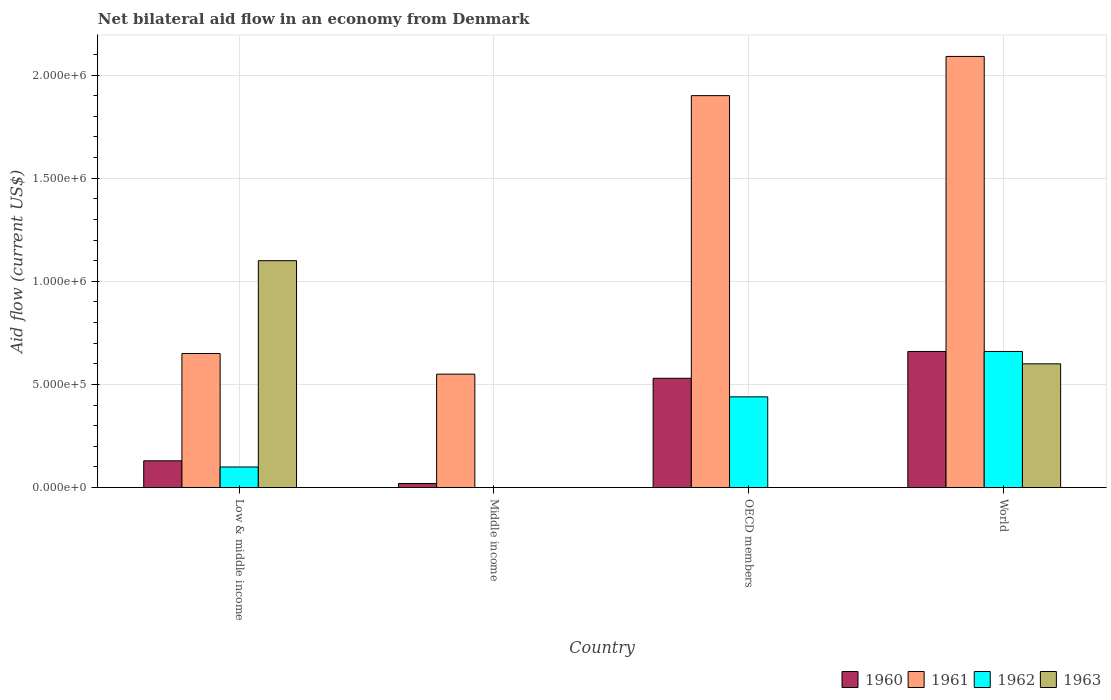How many groups of bars are there?
Keep it short and to the point. 4. How many bars are there on the 2nd tick from the right?
Offer a very short reply. 3. In which country was the net bilateral aid flow in 1963 maximum?
Offer a very short reply. Low & middle income. What is the total net bilateral aid flow in 1961 in the graph?
Provide a short and direct response. 5.19e+06. What is the difference between the net bilateral aid flow in 1960 in Middle income and that in World?
Ensure brevity in your answer.  -6.40e+05. What is the difference between the net bilateral aid flow in 1961 in Middle income and the net bilateral aid flow in 1960 in World?
Make the answer very short. -1.10e+05. What is the average net bilateral aid flow in 1961 per country?
Your response must be concise. 1.30e+06. What is the difference between the net bilateral aid flow of/in 1963 and net bilateral aid flow of/in 1960 in Low & middle income?
Offer a very short reply. 9.70e+05. In how many countries, is the net bilateral aid flow in 1961 greater than 600000 US$?
Keep it short and to the point. 3. What is the ratio of the net bilateral aid flow in 1961 in OECD members to that in World?
Give a very brief answer. 0.91. Is the net bilateral aid flow in 1961 in Middle income less than that in OECD members?
Keep it short and to the point. Yes. What is the difference between the highest and the lowest net bilateral aid flow in 1963?
Your response must be concise. 1.10e+06. Is the sum of the net bilateral aid flow in 1961 in OECD members and World greater than the maximum net bilateral aid flow in 1963 across all countries?
Your answer should be very brief. Yes. Is it the case that in every country, the sum of the net bilateral aid flow in 1963 and net bilateral aid flow in 1961 is greater than the net bilateral aid flow in 1962?
Provide a succinct answer. Yes. Are all the bars in the graph horizontal?
Provide a succinct answer. No. Does the graph contain any zero values?
Give a very brief answer. Yes. Does the graph contain grids?
Keep it short and to the point. Yes. Where does the legend appear in the graph?
Your response must be concise. Bottom right. How many legend labels are there?
Ensure brevity in your answer.  4. What is the title of the graph?
Give a very brief answer. Net bilateral aid flow in an economy from Denmark. What is the Aid flow (current US$) of 1961 in Low & middle income?
Make the answer very short. 6.50e+05. What is the Aid flow (current US$) in 1963 in Low & middle income?
Offer a very short reply. 1.10e+06. What is the Aid flow (current US$) of 1960 in Middle income?
Offer a terse response. 2.00e+04. What is the Aid flow (current US$) of 1962 in Middle income?
Your answer should be very brief. 0. What is the Aid flow (current US$) in 1960 in OECD members?
Offer a very short reply. 5.30e+05. What is the Aid flow (current US$) of 1961 in OECD members?
Make the answer very short. 1.90e+06. What is the Aid flow (current US$) in 1963 in OECD members?
Offer a terse response. 0. What is the Aid flow (current US$) in 1961 in World?
Keep it short and to the point. 2.09e+06. Across all countries, what is the maximum Aid flow (current US$) of 1961?
Offer a very short reply. 2.09e+06. Across all countries, what is the maximum Aid flow (current US$) in 1962?
Your answer should be very brief. 6.60e+05. Across all countries, what is the maximum Aid flow (current US$) of 1963?
Your answer should be compact. 1.10e+06. Across all countries, what is the minimum Aid flow (current US$) in 1960?
Your answer should be compact. 2.00e+04. Across all countries, what is the minimum Aid flow (current US$) of 1963?
Provide a succinct answer. 0. What is the total Aid flow (current US$) in 1960 in the graph?
Keep it short and to the point. 1.34e+06. What is the total Aid flow (current US$) in 1961 in the graph?
Ensure brevity in your answer.  5.19e+06. What is the total Aid flow (current US$) in 1962 in the graph?
Give a very brief answer. 1.20e+06. What is the total Aid flow (current US$) of 1963 in the graph?
Your answer should be very brief. 1.70e+06. What is the difference between the Aid flow (current US$) of 1961 in Low & middle income and that in Middle income?
Offer a terse response. 1.00e+05. What is the difference between the Aid flow (current US$) in 1960 in Low & middle income and that in OECD members?
Provide a succinct answer. -4.00e+05. What is the difference between the Aid flow (current US$) of 1961 in Low & middle income and that in OECD members?
Offer a very short reply. -1.25e+06. What is the difference between the Aid flow (current US$) of 1960 in Low & middle income and that in World?
Offer a very short reply. -5.30e+05. What is the difference between the Aid flow (current US$) of 1961 in Low & middle income and that in World?
Provide a short and direct response. -1.44e+06. What is the difference between the Aid flow (current US$) in 1962 in Low & middle income and that in World?
Your answer should be compact. -5.60e+05. What is the difference between the Aid flow (current US$) in 1960 in Middle income and that in OECD members?
Ensure brevity in your answer.  -5.10e+05. What is the difference between the Aid flow (current US$) of 1961 in Middle income and that in OECD members?
Your response must be concise. -1.35e+06. What is the difference between the Aid flow (current US$) in 1960 in Middle income and that in World?
Keep it short and to the point. -6.40e+05. What is the difference between the Aid flow (current US$) in 1961 in Middle income and that in World?
Your answer should be very brief. -1.54e+06. What is the difference between the Aid flow (current US$) in 1962 in OECD members and that in World?
Offer a terse response. -2.20e+05. What is the difference between the Aid flow (current US$) of 1960 in Low & middle income and the Aid flow (current US$) of 1961 in Middle income?
Give a very brief answer. -4.20e+05. What is the difference between the Aid flow (current US$) of 1960 in Low & middle income and the Aid flow (current US$) of 1961 in OECD members?
Keep it short and to the point. -1.77e+06. What is the difference between the Aid flow (current US$) of 1960 in Low & middle income and the Aid flow (current US$) of 1962 in OECD members?
Offer a terse response. -3.10e+05. What is the difference between the Aid flow (current US$) in 1961 in Low & middle income and the Aid flow (current US$) in 1962 in OECD members?
Your response must be concise. 2.10e+05. What is the difference between the Aid flow (current US$) of 1960 in Low & middle income and the Aid flow (current US$) of 1961 in World?
Your answer should be compact. -1.96e+06. What is the difference between the Aid flow (current US$) in 1960 in Low & middle income and the Aid flow (current US$) in 1962 in World?
Give a very brief answer. -5.30e+05. What is the difference between the Aid flow (current US$) of 1960 in Low & middle income and the Aid flow (current US$) of 1963 in World?
Offer a very short reply. -4.70e+05. What is the difference between the Aid flow (current US$) of 1961 in Low & middle income and the Aid flow (current US$) of 1962 in World?
Keep it short and to the point. -10000. What is the difference between the Aid flow (current US$) in 1962 in Low & middle income and the Aid flow (current US$) in 1963 in World?
Your answer should be compact. -5.00e+05. What is the difference between the Aid flow (current US$) of 1960 in Middle income and the Aid flow (current US$) of 1961 in OECD members?
Offer a very short reply. -1.88e+06. What is the difference between the Aid flow (current US$) of 1960 in Middle income and the Aid flow (current US$) of 1962 in OECD members?
Keep it short and to the point. -4.20e+05. What is the difference between the Aid flow (current US$) in 1960 in Middle income and the Aid flow (current US$) in 1961 in World?
Provide a succinct answer. -2.07e+06. What is the difference between the Aid flow (current US$) in 1960 in Middle income and the Aid flow (current US$) in 1962 in World?
Offer a terse response. -6.40e+05. What is the difference between the Aid flow (current US$) of 1960 in Middle income and the Aid flow (current US$) of 1963 in World?
Give a very brief answer. -5.80e+05. What is the difference between the Aid flow (current US$) in 1960 in OECD members and the Aid flow (current US$) in 1961 in World?
Provide a succinct answer. -1.56e+06. What is the difference between the Aid flow (current US$) of 1960 in OECD members and the Aid flow (current US$) of 1962 in World?
Make the answer very short. -1.30e+05. What is the difference between the Aid flow (current US$) of 1961 in OECD members and the Aid flow (current US$) of 1962 in World?
Your answer should be very brief. 1.24e+06. What is the difference between the Aid flow (current US$) in 1961 in OECD members and the Aid flow (current US$) in 1963 in World?
Ensure brevity in your answer.  1.30e+06. What is the difference between the Aid flow (current US$) of 1962 in OECD members and the Aid flow (current US$) of 1963 in World?
Ensure brevity in your answer.  -1.60e+05. What is the average Aid flow (current US$) of 1960 per country?
Keep it short and to the point. 3.35e+05. What is the average Aid flow (current US$) in 1961 per country?
Offer a terse response. 1.30e+06. What is the average Aid flow (current US$) of 1963 per country?
Offer a very short reply. 4.25e+05. What is the difference between the Aid flow (current US$) of 1960 and Aid flow (current US$) of 1961 in Low & middle income?
Your answer should be compact. -5.20e+05. What is the difference between the Aid flow (current US$) in 1960 and Aid flow (current US$) in 1963 in Low & middle income?
Make the answer very short. -9.70e+05. What is the difference between the Aid flow (current US$) in 1961 and Aid flow (current US$) in 1962 in Low & middle income?
Provide a short and direct response. 5.50e+05. What is the difference between the Aid flow (current US$) of 1961 and Aid flow (current US$) of 1963 in Low & middle income?
Your response must be concise. -4.50e+05. What is the difference between the Aid flow (current US$) in 1962 and Aid flow (current US$) in 1963 in Low & middle income?
Provide a short and direct response. -1.00e+06. What is the difference between the Aid flow (current US$) of 1960 and Aid flow (current US$) of 1961 in Middle income?
Your answer should be compact. -5.30e+05. What is the difference between the Aid flow (current US$) of 1960 and Aid flow (current US$) of 1961 in OECD members?
Your response must be concise. -1.37e+06. What is the difference between the Aid flow (current US$) of 1960 and Aid flow (current US$) of 1962 in OECD members?
Offer a terse response. 9.00e+04. What is the difference between the Aid flow (current US$) in 1961 and Aid flow (current US$) in 1962 in OECD members?
Ensure brevity in your answer.  1.46e+06. What is the difference between the Aid flow (current US$) of 1960 and Aid flow (current US$) of 1961 in World?
Your response must be concise. -1.43e+06. What is the difference between the Aid flow (current US$) of 1960 and Aid flow (current US$) of 1962 in World?
Offer a terse response. 0. What is the difference between the Aid flow (current US$) in 1961 and Aid flow (current US$) in 1962 in World?
Give a very brief answer. 1.43e+06. What is the difference between the Aid flow (current US$) of 1961 and Aid flow (current US$) of 1963 in World?
Make the answer very short. 1.49e+06. What is the difference between the Aid flow (current US$) of 1962 and Aid flow (current US$) of 1963 in World?
Give a very brief answer. 6.00e+04. What is the ratio of the Aid flow (current US$) in 1961 in Low & middle income to that in Middle income?
Provide a succinct answer. 1.18. What is the ratio of the Aid flow (current US$) in 1960 in Low & middle income to that in OECD members?
Ensure brevity in your answer.  0.25. What is the ratio of the Aid flow (current US$) in 1961 in Low & middle income to that in OECD members?
Keep it short and to the point. 0.34. What is the ratio of the Aid flow (current US$) of 1962 in Low & middle income to that in OECD members?
Your response must be concise. 0.23. What is the ratio of the Aid flow (current US$) of 1960 in Low & middle income to that in World?
Your response must be concise. 0.2. What is the ratio of the Aid flow (current US$) of 1961 in Low & middle income to that in World?
Provide a short and direct response. 0.31. What is the ratio of the Aid flow (current US$) in 1962 in Low & middle income to that in World?
Give a very brief answer. 0.15. What is the ratio of the Aid flow (current US$) in 1963 in Low & middle income to that in World?
Your answer should be compact. 1.83. What is the ratio of the Aid flow (current US$) of 1960 in Middle income to that in OECD members?
Your answer should be compact. 0.04. What is the ratio of the Aid flow (current US$) of 1961 in Middle income to that in OECD members?
Make the answer very short. 0.29. What is the ratio of the Aid flow (current US$) of 1960 in Middle income to that in World?
Give a very brief answer. 0.03. What is the ratio of the Aid flow (current US$) in 1961 in Middle income to that in World?
Keep it short and to the point. 0.26. What is the ratio of the Aid flow (current US$) of 1960 in OECD members to that in World?
Offer a very short reply. 0.8. What is the difference between the highest and the second highest Aid flow (current US$) of 1961?
Your answer should be very brief. 1.90e+05. What is the difference between the highest and the second highest Aid flow (current US$) in 1962?
Make the answer very short. 2.20e+05. What is the difference between the highest and the lowest Aid flow (current US$) of 1960?
Keep it short and to the point. 6.40e+05. What is the difference between the highest and the lowest Aid flow (current US$) of 1961?
Ensure brevity in your answer.  1.54e+06. What is the difference between the highest and the lowest Aid flow (current US$) of 1963?
Ensure brevity in your answer.  1.10e+06. 